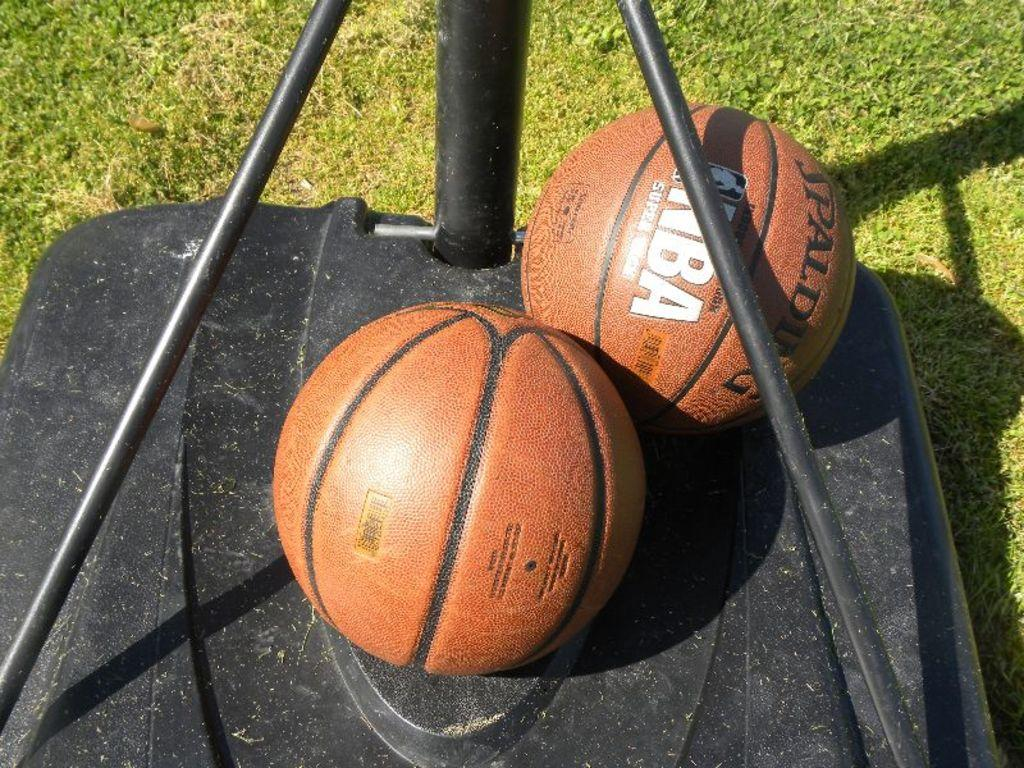How many balls are present in the image? A: There are two balls in the image. What else can be seen in the image besides the balls? There is an object and grass in the image. What type of canvas is being used for the treatment in the image? There is no canvas or treatment present in the image; it features two balls and an object on grass. 